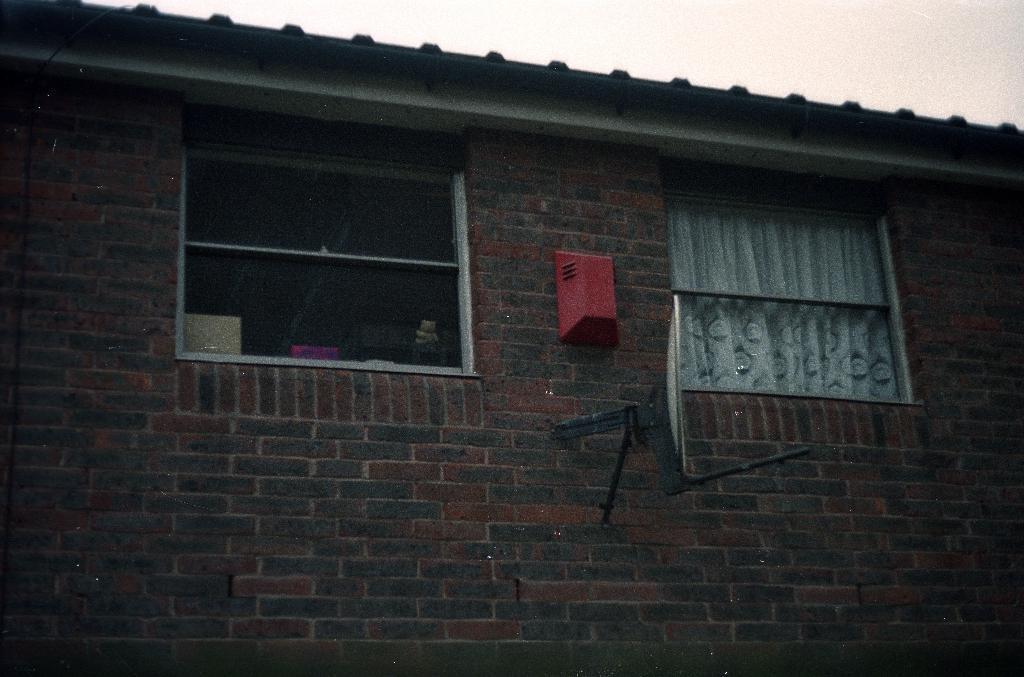What type of structure is present in the image? There is a building in the image. What can be seen near the window of the building? There is a curtain to the window in the image. What is attached to the wall of the building? There is an antenna attached to the wall in the image. What is visible in the background of the image? The sky is visible in the image. What type of stocking is hanging from the antenna in the image? There is no stocking present in the image, nor is there any hanging from the antenna. 